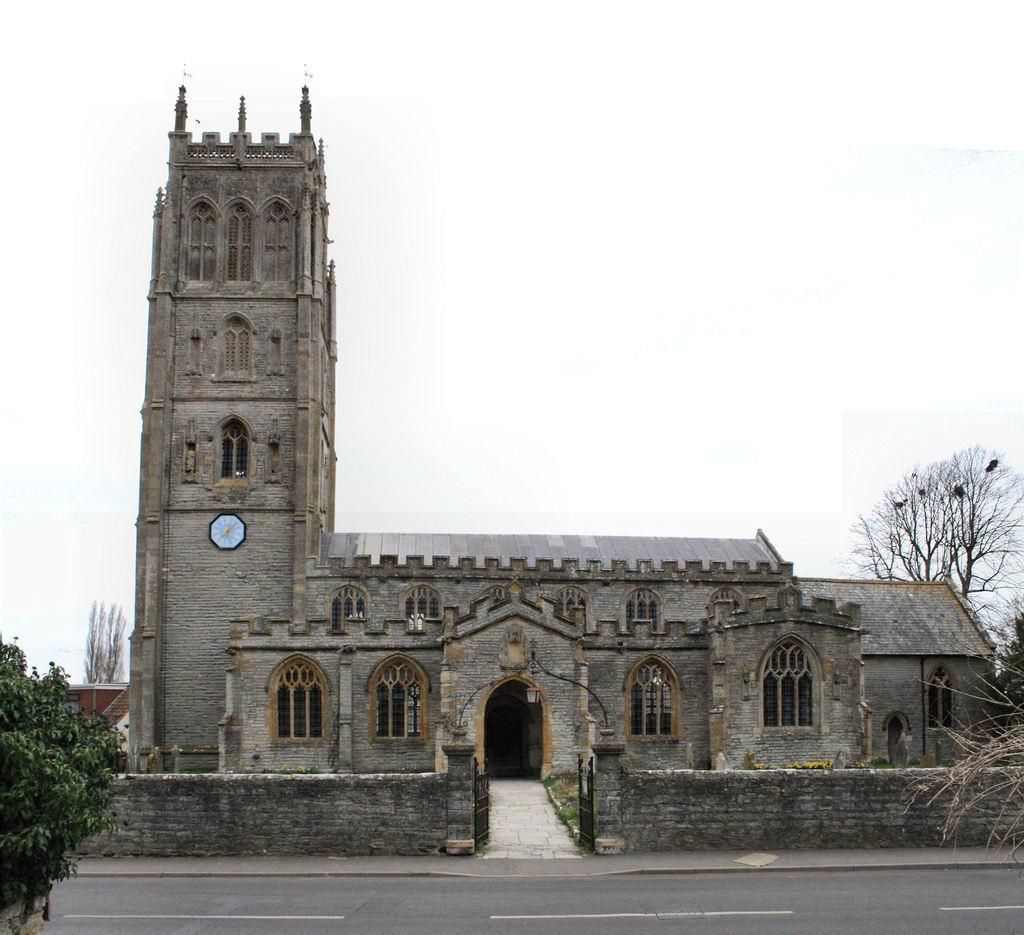Please provide a concise description of this image. In this image in the center there is one building, and on the building there is one clock and in the foreground there are some plants and trees. At the bottom there is road and at the top of the image there is sky, and in the background there are some houses. 